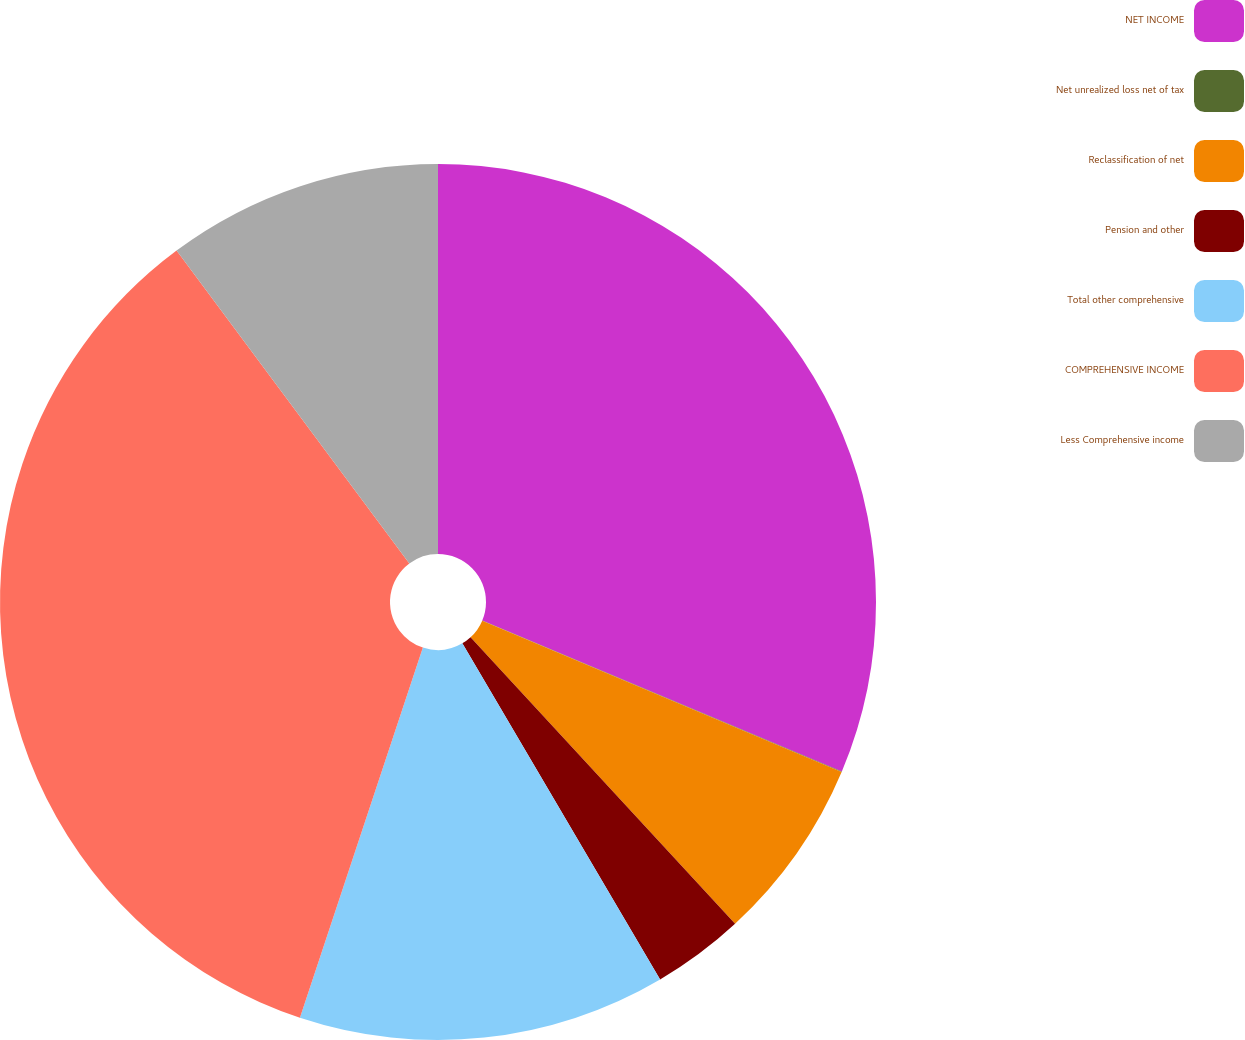Convert chart. <chart><loc_0><loc_0><loc_500><loc_500><pie_chart><fcel>NET INCOME<fcel>Net unrealized loss net of tax<fcel>Reclassification of net<fcel>Pension and other<fcel>Total other comprehensive<fcel>COMPREHENSIVE INCOME<fcel>Less Comprehensive income<nl><fcel>31.33%<fcel>0.02%<fcel>6.79%<fcel>3.4%<fcel>13.57%<fcel>34.72%<fcel>10.18%<nl></chart> 